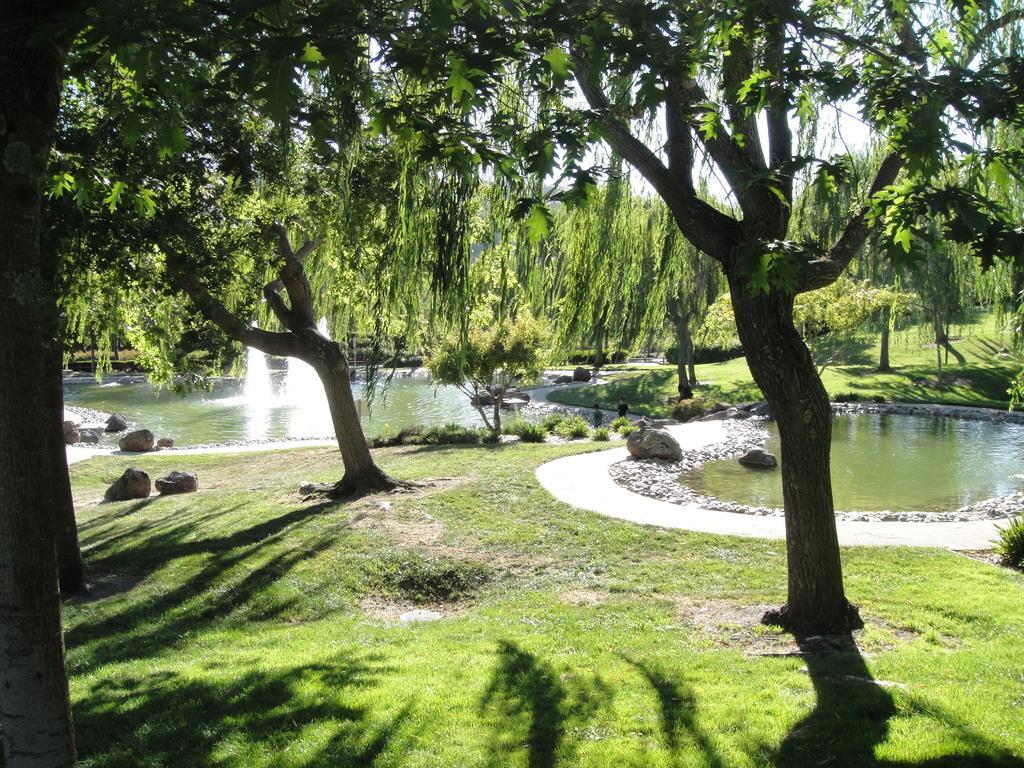Could you give a brief overview of what you see in this image? In this image there are trees on the ground. There are rocks and grass on the ground. To the right there is a water pool. To the left there is a fountain in the water pool. In the background there are trees. At the top there is the sky. 